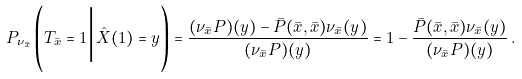<formula> <loc_0><loc_0><loc_500><loc_500>P _ { \nu _ { \bar { x } } } \left ( T _ { \bar { x } } = 1 \Big | \hat { X } ( 1 ) = y \right ) = \frac { ( \nu _ { \bar { x } } P ) ( y ) - \bar { P } ( \bar { x } , \bar { x } ) \nu _ { \bar { x } } ( y ) } { ( \nu _ { \bar { x } } P ) ( y ) } = 1 - \frac { \bar { P } ( \bar { x } , \bar { x } ) \nu _ { \bar { x } } ( y ) } { ( \nu _ { \bar { x } } P ) ( y ) } \, .</formula> 